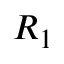<formula> <loc_0><loc_0><loc_500><loc_500>R _ { 1 }</formula> 